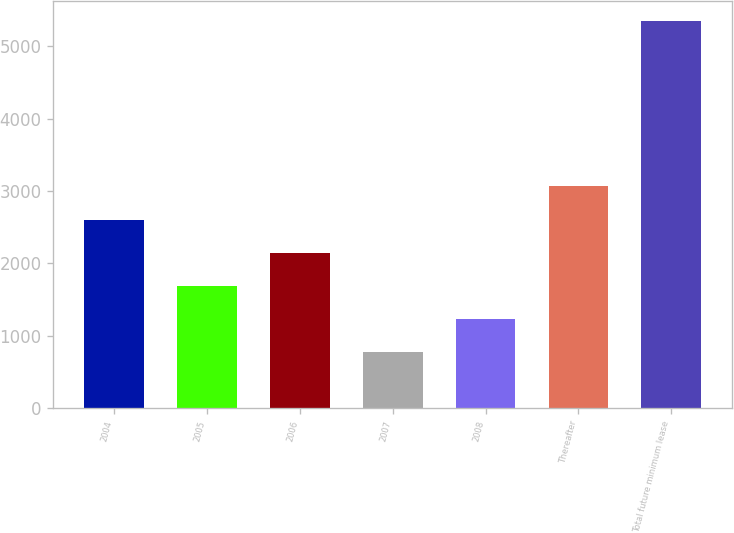Convert chart. <chart><loc_0><loc_0><loc_500><loc_500><bar_chart><fcel>2004<fcel>2005<fcel>2006<fcel>2007<fcel>2008<fcel>Thereafter<fcel>Total future minimum lease<nl><fcel>2603<fcel>1686<fcel>2144.5<fcel>769<fcel>1227.5<fcel>3061.5<fcel>5354<nl></chart> 